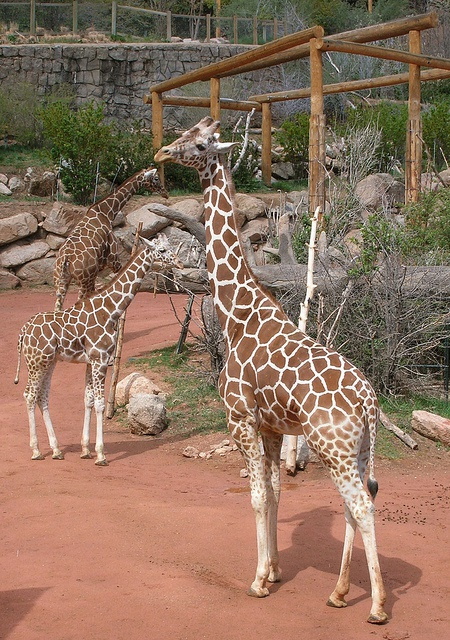Describe the objects in this image and their specific colors. I can see giraffe in black, gray, white, brown, and tan tones, giraffe in black, gray, lightgray, brown, and darkgray tones, and giraffe in black, maroon, and gray tones in this image. 